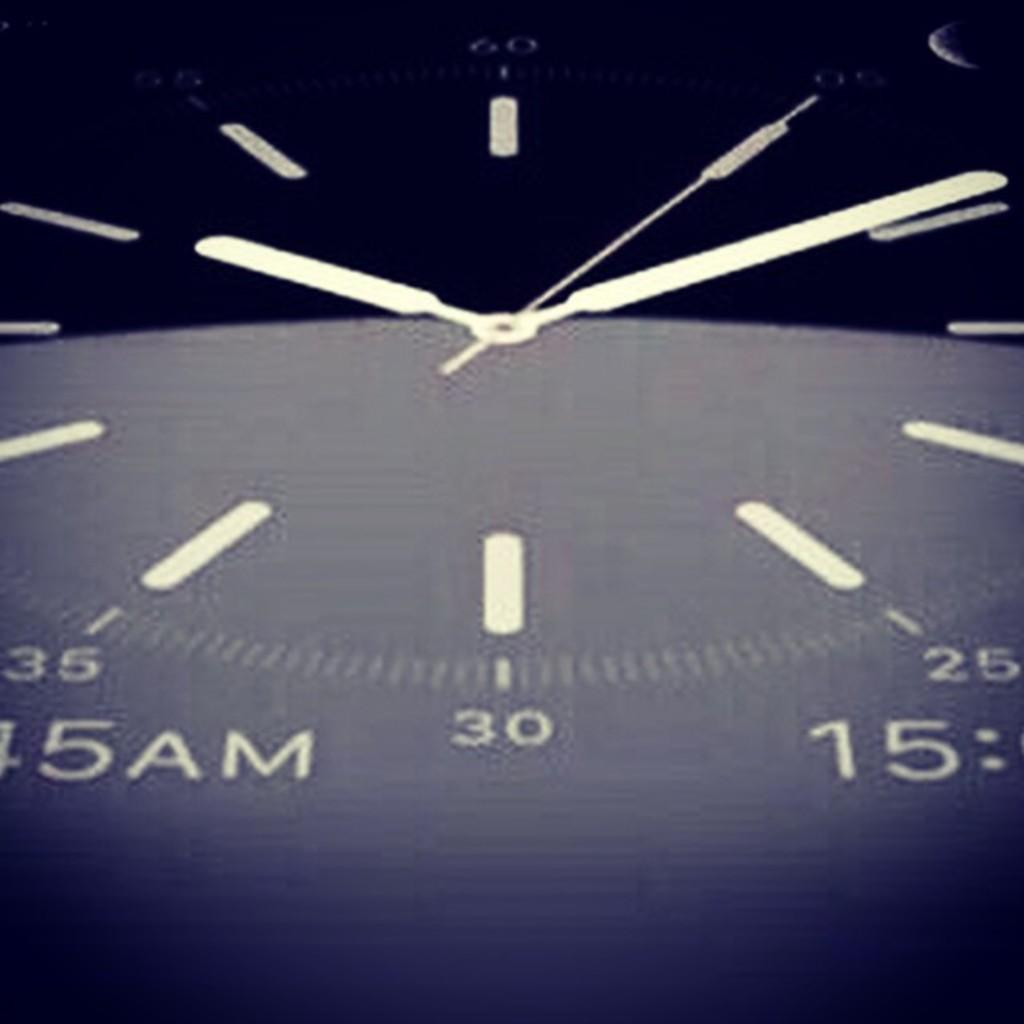<image>
Render a clear and concise summary of the photo. the label 5am that is on a clock 